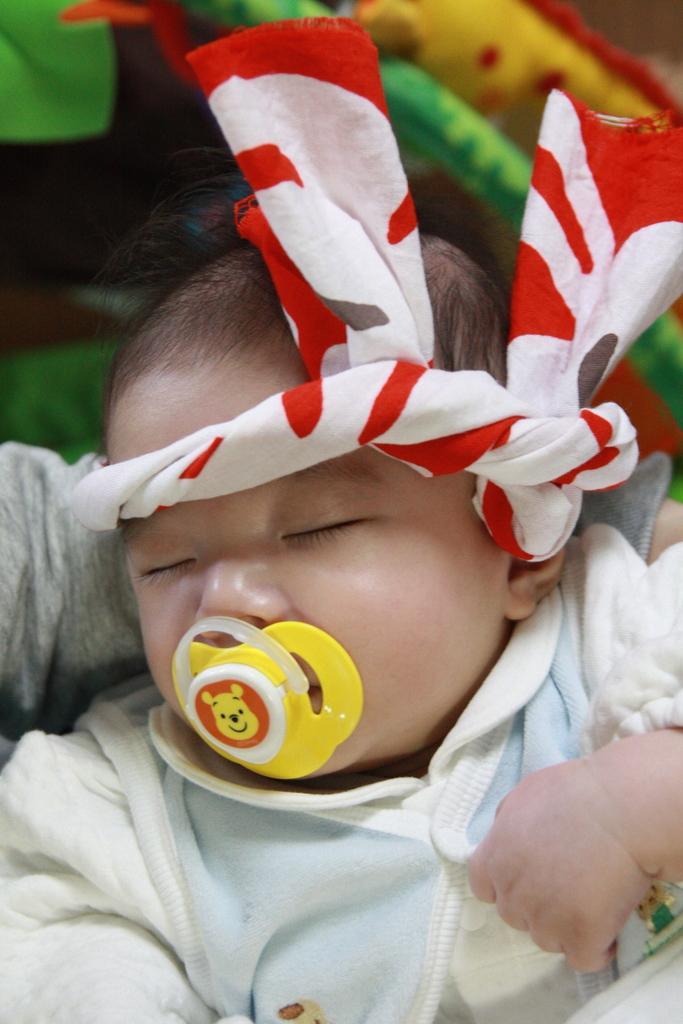Could you give a brief overview of what you see in this image? This image is taken indoors. In the background there is a baby carrier. In the middle of the image there is a baby. 